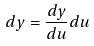Convert formula to latex. <formula><loc_0><loc_0><loc_500><loc_500>d y = \frac { d y } { d u } d u</formula> 